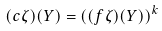<formula> <loc_0><loc_0><loc_500><loc_500>( c \zeta ) ( Y ) = \left ( ( f \zeta ) ( Y ) \right ) ^ { k }</formula> 